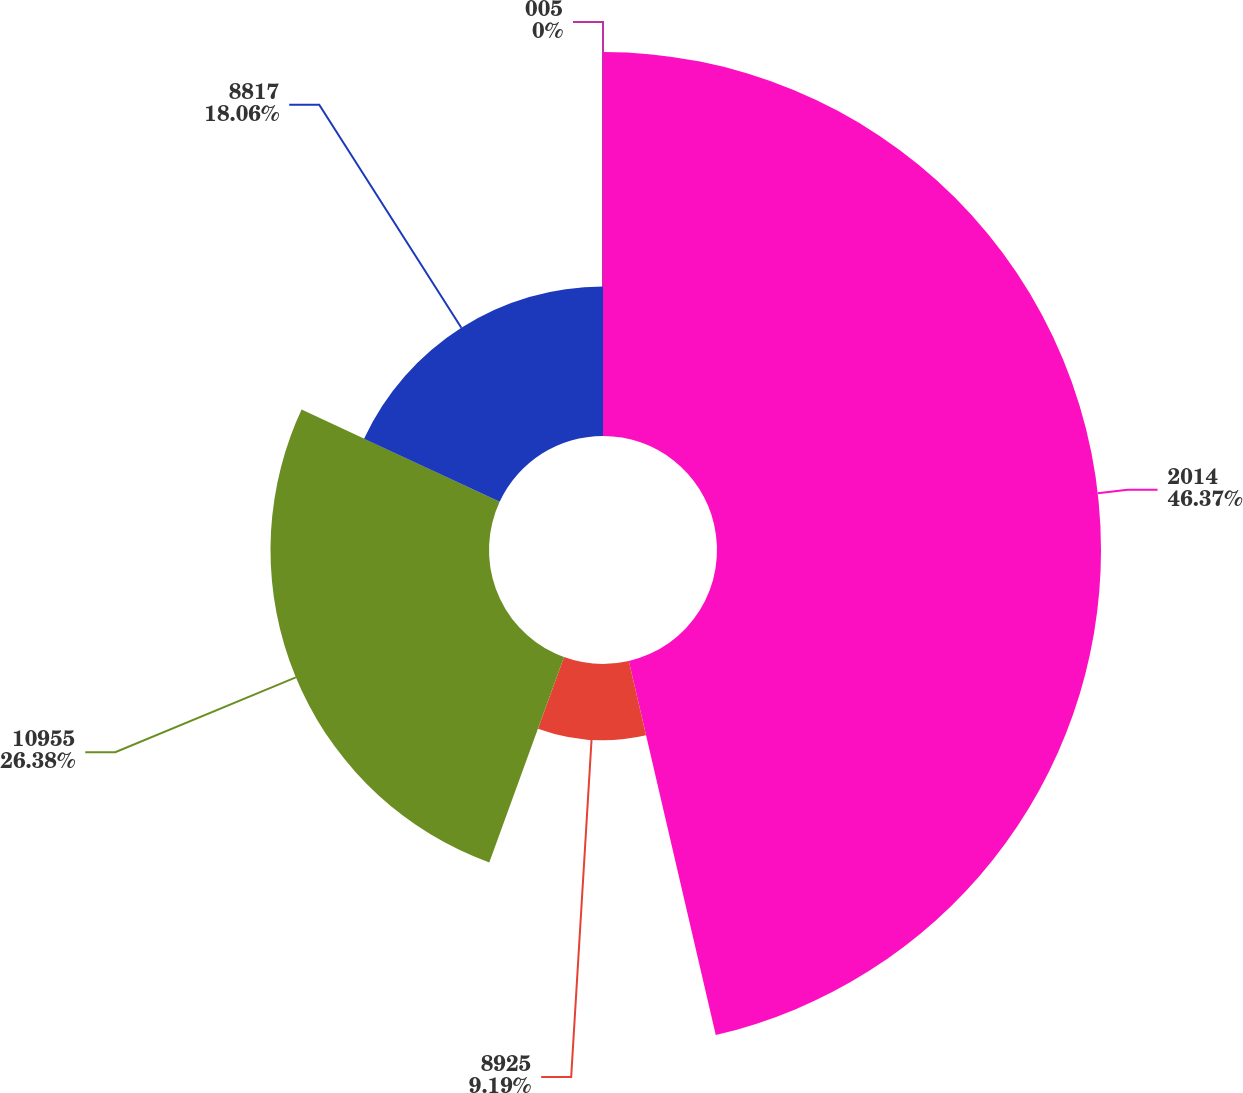Convert chart. <chart><loc_0><loc_0><loc_500><loc_500><pie_chart><fcel>2014<fcel>8925<fcel>10955<fcel>8817<fcel>005<nl><fcel>46.36%<fcel>9.19%<fcel>26.38%<fcel>18.06%<fcel>0.0%<nl></chart> 